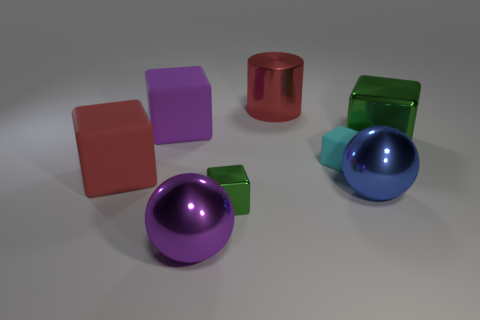Imagine if these objects had personalities, what might they be like based on their colors and positions? In a playful interpretation, the vibrant purple and blue balls could be seen as bubbly and energetic siblings often found side by side. The cubes could represent a diverse group of friends: the green cube is small and unassuming, keeping close to the strong-willed blue sibling; the red cube appears confident and sturdy; the cyan cube, being the smallest, might have a quirky and whimsical nature; and the purple cube, identical in size to the red, could have a calm and poised personality. The red cylinder might be the wise elder of the group, standing solidly in the center. 